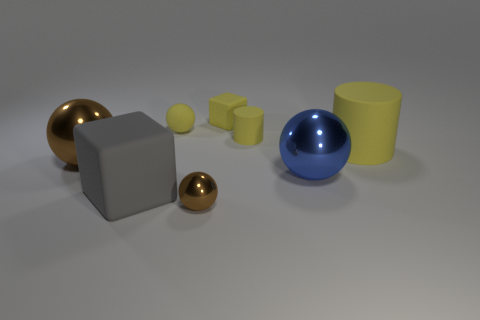Add 2 large gray rubber spheres. How many objects exist? 10 Subtract all cubes. How many objects are left? 6 Subtract all big purple matte cubes. Subtract all tiny yellow matte blocks. How many objects are left? 7 Add 7 brown metallic spheres. How many brown metallic spheres are left? 9 Add 1 gray matte objects. How many gray matte objects exist? 2 Subtract 0 red cylinders. How many objects are left? 8 